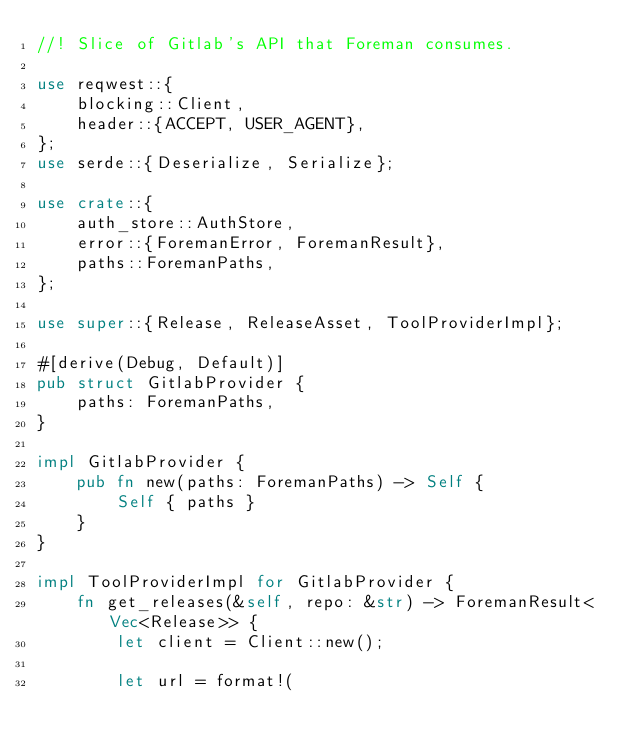<code> <loc_0><loc_0><loc_500><loc_500><_Rust_>//! Slice of Gitlab's API that Foreman consumes.

use reqwest::{
    blocking::Client,
    header::{ACCEPT, USER_AGENT},
};
use serde::{Deserialize, Serialize};

use crate::{
    auth_store::AuthStore,
    error::{ForemanError, ForemanResult},
    paths::ForemanPaths,
};

use super::{Release, ReleaseAsset, ToolProviderImpl};

#[derive(Debug, Default)]
pub struct GitlabProvider {
    paths: ForemanPaths,
}

impl GitlabProvider {
    pub fn new(paths: ForemanPaths) -> Self {
        Self { paths }
    }
}

impl ToolProviderImpl for GitlabProvider {
    fn get_releases(&self, repo: &str) -> ForemanResult<Vec<Release>> {
        let client = Client::new();

        let url = format!(</code> 